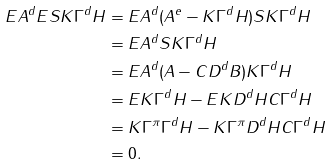Convert formula to latex. <formula><loc_0><loc_0><loc_500><loc_500>E A ^ { d } E S K \Gamma ^ { d } H & = E A ^ { d } ( A ^ { e } - K \Gamma ^ { d } H ) S K \Gamma ^ { d } H \\ & = E A ^ { d } S K \Gamma ^ { d } H \\ & = E A ^ { d } ( A - C D ^ { d } B ) K \Gamma ^ { d } H \\ & = E K \Gamma ^ { d } H - E K D ^ { d } H C \Gamma ^ { d } H \\ & = K \Gamma ^ { \pi } \Gamma ^ { d } H - K \Gamma ^ { \pi } D ^ { d } H C \Gamma ^ { d } H \\ & = 0 .</formula> 